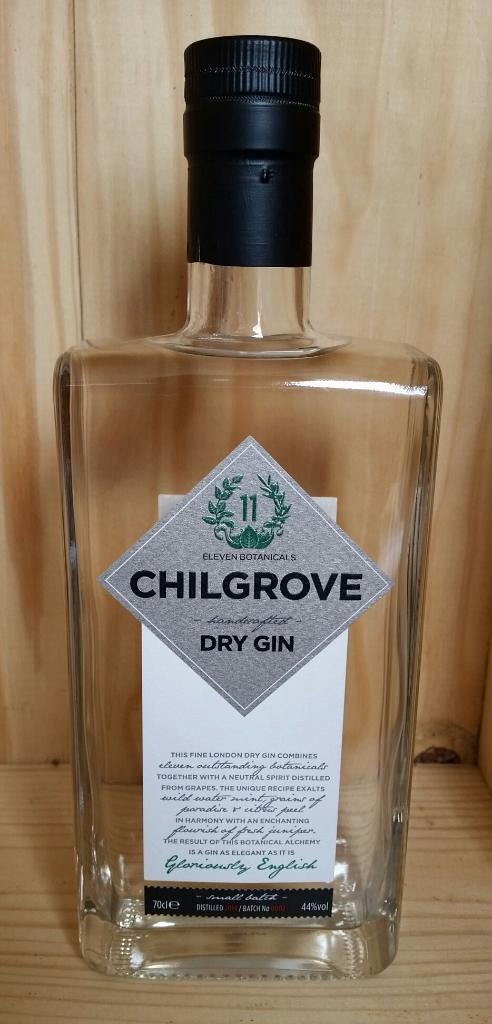<image>
Offer a succinct explanation of the picture presented. Empty bottle of Chilgrove Dry Gin is depicted. 